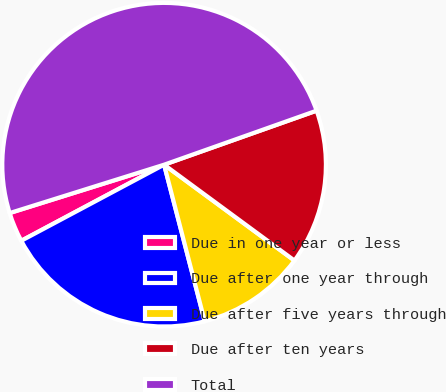Convert chart. <chart><loc_0><loc_0><loc_500><loc_500><pie_chart><fcel>Due in one year or less<fcel>Due after one year through<fcel>Due after five years through<fcel>Due after ten years<fcel>Total<nl><fcel>2.96%<fcel>21.25%<fcel>10.87%<fcel>15.51%<fcel>49.41%<nl></chart> 